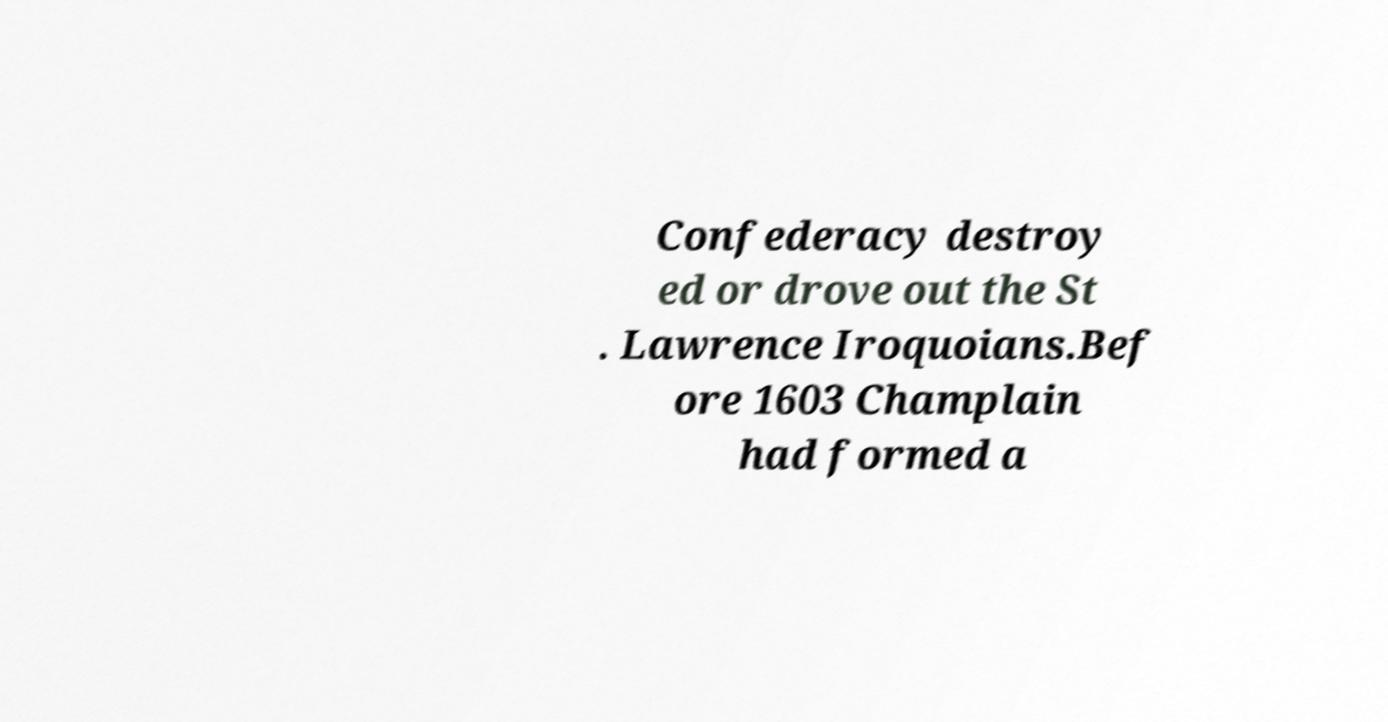For documentation purposes, I need the text within this image transcribed. Could you provide that? Confederacy destroy ed or drove out the St . Lawrence Iroquoians.Bef ore 1603 Champlain had formed a 